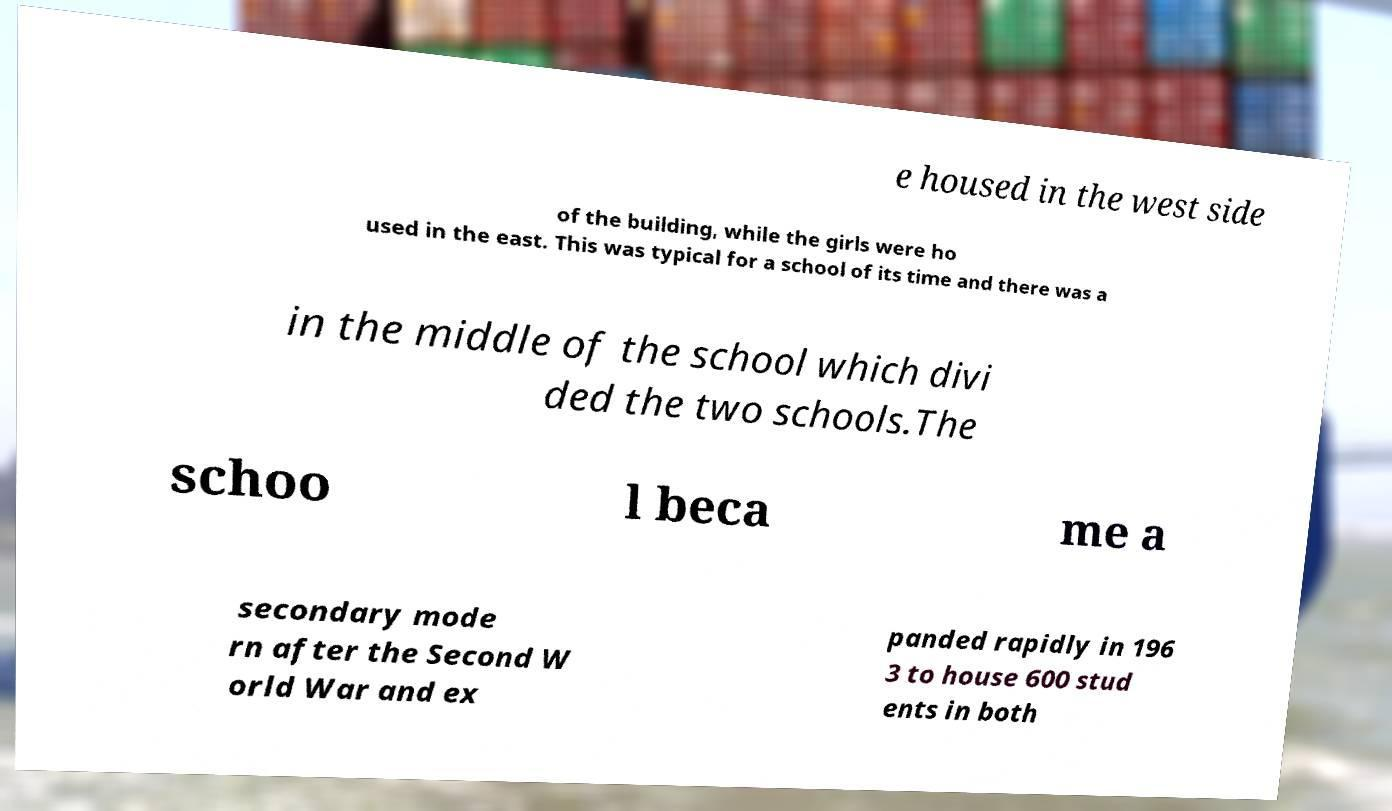For documentation purposes, I need the text within this image transcribed. Could you provide that? e housed in the west side of the building, while the girls were ho used in the east. This was typical for a school of its time and there was a in the middle of the school which divi ded the two schools.The schoo l beca me a secondary mode rn after the Second W orld War and ex panded rapidly in 196 3 to house 600 stud ents in both 